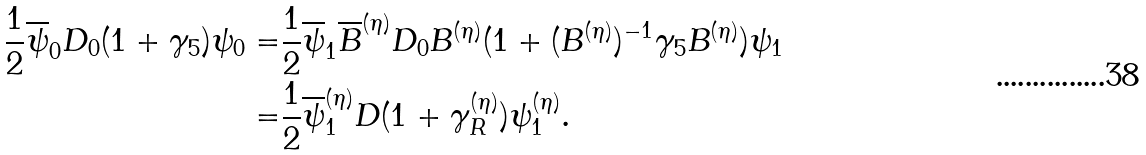<formula> <loc_0><loc_0><loc_500><loc_500>\frac { 1 } { 2 } \overline { \psi } _ { 0 } D _ { 0 } ( 1 + \gamma _ { 5 } ) \psi _ { 0 } = & \frac { 1 } { 2 } \overline { \psi } _ { 1 } \overline { B } ^ { ( \eta ) } D _ { 0 } B ^ { ( \eta ) } ( 1 + ( B ^ { ( \eta ) } ) ^ { - 1 } \gamma _ { 5 } B ^ { ( \eta ) } ) \psi _ { 1 } \\ = & \frac { 1 } { 2 } \overline { \psi } _ { 1 } ^ { ( \eta ) } D ( 1 + \gamma _ { R } ^ { ( \eta ) } ) \psi _ { 1 } ^ { ( \eta ) } .</formula> 